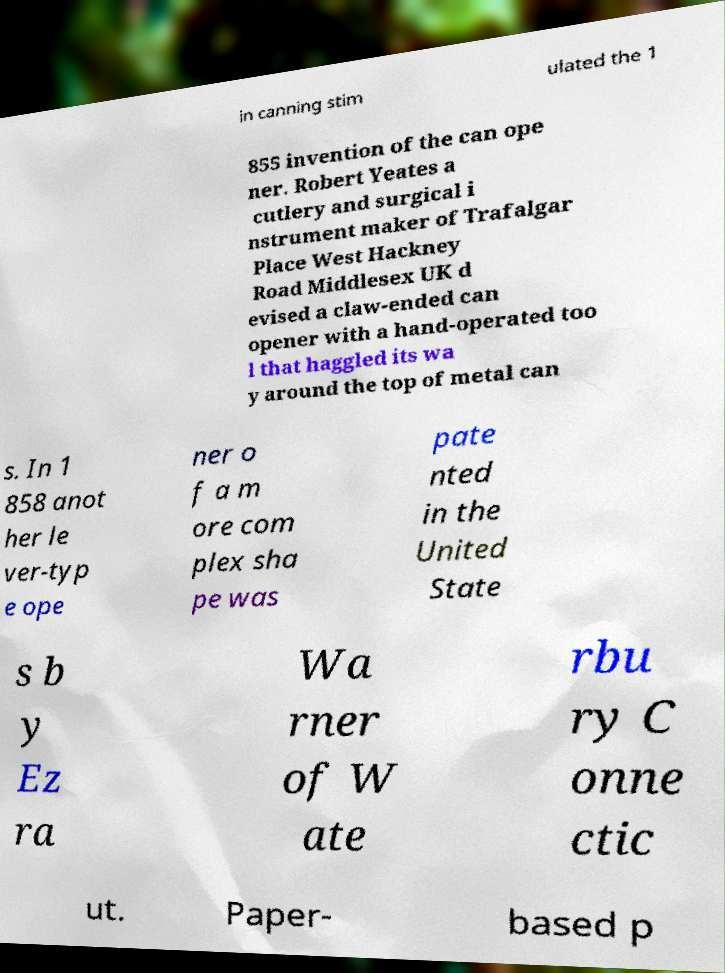There's text embedded in this image that I need extracted. Can you transcribe it verbatim? in canning stim ulated the 1 855 invention of the can ope ner. Robert Yeates a cutlery and surgical i nstrument maker of Trafalgar Place West Hackney Road Middlesex UK d evised a claw-ended can opener with a hand-operated too l that haggled its wa y around the top of metal can s. In 1 858 anot her le ver-typ e ope ner o f a m ore com plex sha pe was pate nted in the United State s b y Ez ra Wa rner of W ate rbu ry C onne ctic ut. Paper- based p 